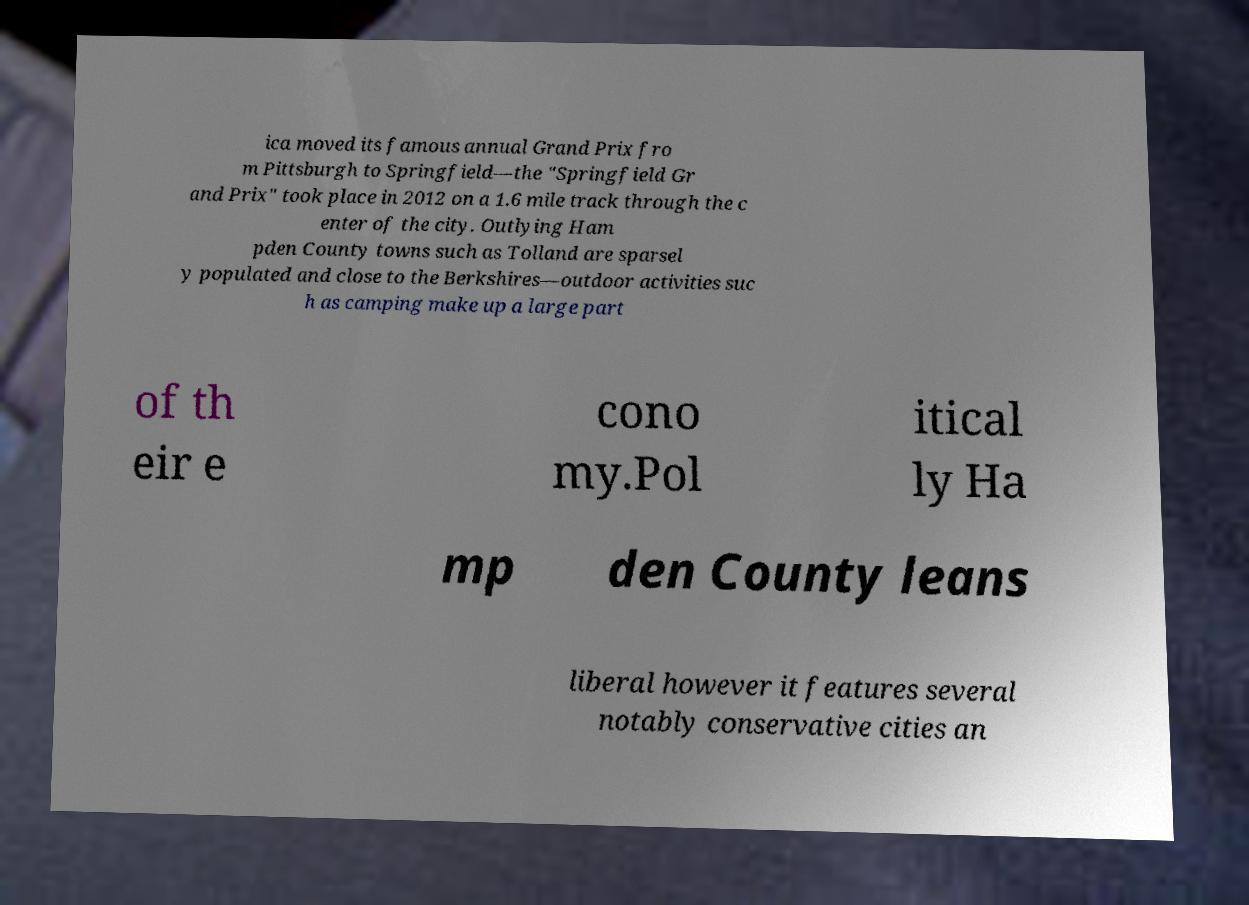What messages or text are displayed in this image? I need them in a readable, typed format. ica moved its famous annual Grand Prix fro m Pittsburgh to Springfield—the "Springfield Gr and Prix" took place in 2012 on a 1.6 mile track through the c enter of the city. Outlying Ham pden County towns such as Tolland are sparsel y populated and close to the Berkshires—outdoor activities suc h as camping make up a large part of th eir e cono my.Pol itical ly Ha mp den County leans liberal however it features several notably conservative cities an 